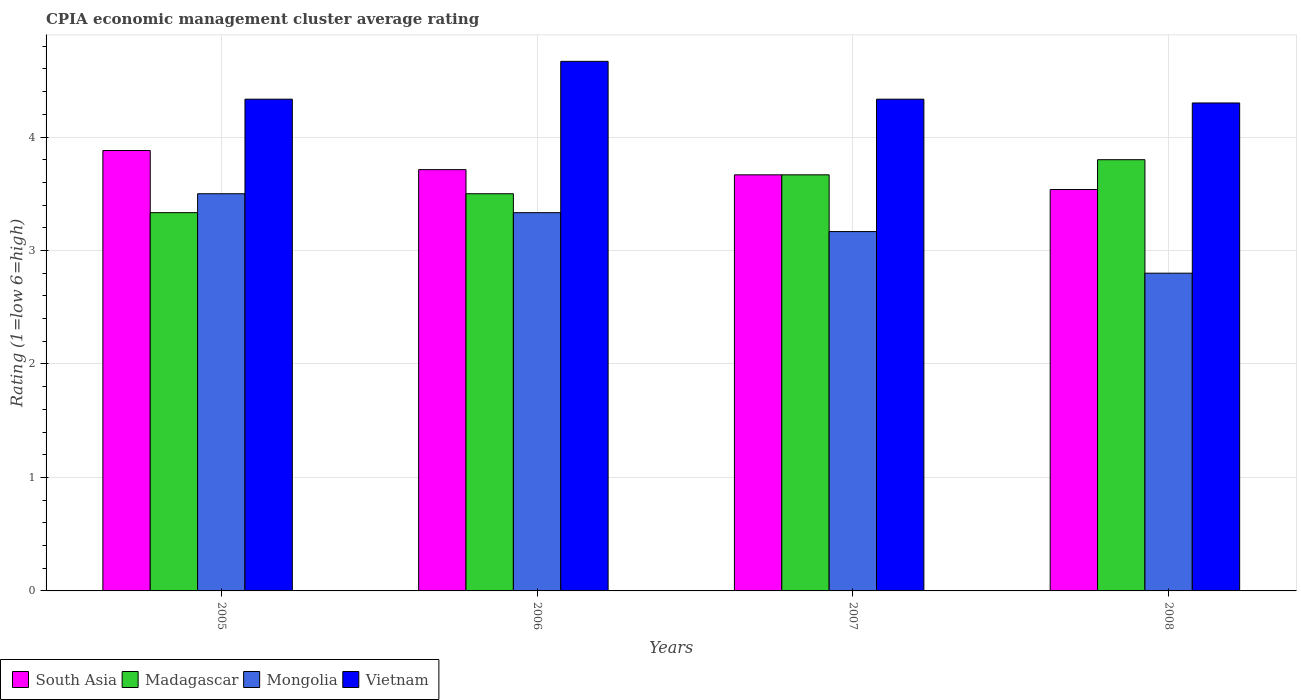Are the number of bars per tick equal to the number of legend labels?
Your response must be concise. Yes. Are the number of bars on each tick of the X-axis equal?
Keep it short and to the point. Yes. How many bars are there on the 2nd tick from the left?
Offer a terse response. 4. How many bars are there on the 1st tick from the right?
Give a very brief answer. 4. What is the label of the 2nd group of bars from the left?
Keep it short and to the point. 2006. In how many cases, is the number of bars for a given year not equal to the number of legend labels?
Offer a terse response. 0. What is the CPIA rating in South Asia in 2006?
Give a very brief answer. 3.71. Across all years, what is the minimum CPIA rating in South Asia?
Provide a succinct answer. 3.54. In which year was the CPIA rating in Mongolia minimum?
Keep it short and to the point. 2008. What is the total CPIA rating in Vietnam in the graph?
Provide a succinct answer. 17.63. What is the difference between the CPIA rating in South Asia in 2007 and that in 2008?
Provide a short and direct response. 0.13. What is the difference between the CPIA rating in Madagascar in 2007 and the CPIA rating in South Asia in 2006?
Provide a succinct answer. -0.05. In the year 2006, what is the difference between the CPIA rating in Madagascar and CPIA rating in Mongolia?
Offer a terse response. 0.17. In how many years, is the CPIA rating in Vietnam greater than 3.8?
Give a very brief answer. 4. What is the ratio of the CPIA rating in Vietnam in 2005 to that in 2007?
Your response must be concise. 1. Is the difference between the CPIA rating in Madagascar in 2005 and 2007 greater than the difference between the CPIA rating in Mongolia in 2005 and 2007?
Your answer should be compact. No. What is the difference between the highest and the second highest CPIA rating in Mongolia?
Provide a short and direct response. 0.17. What is the difference between the highest and the lowest CPIA rating in Mongolia?
Give a very brief answer. 0.7. Is the sum of the CPIA rating in Vietnam in 2005 and 2008 greater than the maximum CPIA rating in Mongolia across all years?
Your response must be concise. Yes. What does the 3rd bar from the left in 2008 represents?
Provide a succinct answer. Mongolia. What does the 1st bar from the right in 2006 represents?
Your answer should be compact. Vietnam. Is it the case that in every year, the sum of the CPIA rating in Madagascar and CPIA rating in Vietnam is greater than the CPIA rating in South Asia?
Give a very brief answer. Yes. How many bars are there?
Offer a terse response. 16. How many years are there in the graph?
Provide a short and direct response. 4. What is the difference between two consecutive major ticks on the Y-axis?
Provide a short and direct response. 1. Does the graph contain any zero values?
Make the answer very short. No. Where does the legend appear in the graph?
Your answer should be very brief. Bottom left. How many legend labels are there?
Ensure brevity in your answer.  4. How are the legend labels stacked?
Offer a terse response. Horizontal. What is the title of the graph?
Your answer should be very brief. CPIA economic management cluster average rating. Does "Brazil" appear as one of the legend labels in the graph?
Make the answer very short. No. What is the Rating (1=low 6=high) in South Asia in 2005?
Provide a short and direct response. 3.88. What is the Rating (1=low 6=high) of Madagascar in 2005?
Ensure brevity in your answer.  3.33. What is the Rating (1=low 6=high) in Mongolia in 2005?
Give a very brief answer. 3.5. What is the Rating (1=low 6=high) of Vietnam in 2005?
Keep it short and to the point. 4.33. What is the Rating (1=low 6=high) in South Asia in 2006?
Give a very brief answer. 3.71. What is the Rating (1=low 6=high) in Mongolia in 2006?
Offer a terse response. 3.33. What is the Rating (1=low 6=high) of Vietnam in 2006?
Keep it short and to the point. 4.67. What is the Rating (1=low 6=high) in South Asia in 2007?
Provide a short and direct response. 3.67. What is the Rating (1=low 6=high) of Madagascar in 2007?
Make the answer very short. 3.67. What is the Rating (1=low 6=high) in Mongolia in 2007?
Your response must be concise. 3.17. What is the Rating (1=low 6=high) in Vietnam in 2007?
Give a very brief answer. 4.33. What is the Rating (1=low 6=high) in South Asia in 2008?
Offer a very short reply. 3.54. Across all years, what is the maximum Rating (1=low 6=high) of South Asia?
Make the answer very short. 3.88. Across all years, what is the maximum Rating (1=low 6=high) of Vietnam?
Offer a very short reply. 4.67. Across all years, what is the minimum Rating (1=low 6=high) in South Asia?
Keep it short and to the point. 3.54. Across all years, what is the minimum Rating (1=low 6=high) of Madagascar?
Your answer should be compact. 3.33. What is the total Rating (1=low 6=high) in South Asia in the graph?
Your answer should be very brief. 14.8. What is the total Rating (1=low 6=high) in Madagascar in the graph?
Keep it short and to the point. 14.3. What is the total Rating (1=low 6=high) in Vietnam in the graph?
Offer a terse response. 17.63. What is the difference between the Rating (1=low 6=high) of South Asia in 2005 and that in 2006?
Your answer should be compact. 0.17. What is the difference between the Rating (1=low 6=high) of Madagascar in 2005 and that in 2006?
Your response must be concise. -0.17. What is the difference between the Rating (1=low 6=high) of Vietnam in 2005 and that in 2006?
Provide a short and direct response. -0.33. What is the difference between the Rating (1=low 6=high) of South Asia in 2005 and that in 2007?
Offer a very short reply. 0.21. What is the difference between the Rating (1=low 6=high) in Madagascar in 2005 and that in 2007?
Provide a short and direct response. -0.33. What is the difference between the Rating (1=low 6=high) in South Asia in 2005 and that in 2008?
Offer a very short reply. 0.34. What is the difference between the Rating (1=low 6=high) in Madagascar in 2005 and that in 2008?
Give a very brief answer. -0.47. What is the difference between the Rating (1=low 6=high) in Mongolia in 2005 and that in 2008?
Your response must be concise. 0.7. What is the difference between the Rating (1=low 6=high) in Vietnam in 2005 and that in 2008?
Keep it short and to the point. 0.03. What is the difference between the Rating (1=low 6=high) of South Asia in 2006 and that in 2007?
Your response must be concise. 0.05. What is the difference between the Rating (1=low 6=high) in Madagascar in 2006 and that in 2007?
Make the answer very short. -0.17. What is the difference between the Rating (1=low 6=high) in Mongolia in 2006 and that in 2007?
Ensure brevity in your answer.  0.17. What is the difference between the Rating (1=low 6=high) in South Asia in 2006 and that in 2008?
Ensure brevity in your answer.  0.17. What is the difference between the Rating (1=low 6=high) of Mongolia in 2006 and that in 2008?
Provide a short and direct response. 0.53. What is the difference between the Rating (1=low 6=high) in Vietnam in 2006 and that in 2008?
Provide a short and direct response. 0.37. What is the difference between the Rating (1=low 6=high) of South Asia in 2007 and that in 2008?
Provide a succinct answer. 0.13. What is the difference between the Rating (1=low 6=high) of Madagascar in 2007 and that in 2008?
Give a very brief answer. -0.13. What is the difference between the Rating (1=low 6=high) of Mongolia in 2007 and that in 2008?
Ensure brevity in your answer.  0.37. What is the difference between the Rating (1=low 6=high) of Vietnam in 2007 and that in 2008?
Make the answer very short. 0.03. What is the difference between the Rating (1=low 6=high) in South Asia in 2005 and the Rating (1=low 6=high) in Madagascar in 2006?
Your response must be concise. 0.38. What is the difference between the Rating (1=low 6=high) in South Asia in 2005 and the Rating (1=low 6=high) in Mongolia in 2006?
Ensure brevity in your answer.  0.55. What is the difference between the Rating (1=low 6=high) of South Asia in 2005 and the Rating (1=low 6=high) of Vietnam in 2006?
Provide a short and direct response. -0.79. What is the difference between the Rating (1=low 6=high) of Madagascar in 2005 and the Rating (1=low 6=high) of Vietnam in 2006?
Ensure brevity in your answer.  -1.33. What is the difference between the Rating (1=low 6=high) in Mongolia in 2005 and the Rating (1=low 6=high) in Vietnam in 2006?
Keep it short and to the point. -1.17. What is the difference between the Rating (1=low 6=high) of South Asia in 2005 and the Rating (1=low 6=high) of Madagascar in 2007?
Provide a short and direct response. 0.21. What is the difference between the Rating (1=low 6=high) of South Asia in 2005 and the Rating (1=low 6=high) of Mongolia in 2007?
Your answer should be very brief. 0.71. What is the difference between the Rating (1=low 6=high) of South Asia in 2005 and the Rating (1=low 6=high) of Vietnam in 2007?
Offer a very short reply. -0.45. What is the difference between the Rating (1=low 6=high) in Madagascar in 2005 and the Rating (1=low 6=high) in Mongolia in 2007?
Provide a succinct answer. 0.17. What is the difference between the Rating (1=low 6=high) of Madagascar in 2005 and the Rating (1=low 6=high) of Vietnam in 2007?
Your answer should be compact. -1. What is the difference between the Rating (1=low 6=high) of Mongolia in 2005 and the Rating (1=low 6=high) of Vietnam in 2007?
Provide a succinct answer. -0.83. What is the difference between the Rating (1=low 6=high) of South Asia in 2005 and the Rating (1=low 6=high) of Madagascar in 2008?
Provide a short and direct response. 0.08. What is the difference between the Rating (1=low 6=high) in South Asia in 2005 and the Rating (1=low 6=high) in Mongolia in 2008?
Provide a succinct answer. 1.08. What is the difference between the Rating (1=low 6=high) of South Asia in 2005 and the Rating (1=low 6=high) of Vietnam in 2008?
Ensure brevity in your answer.  -0.42. What is the difference between the Rating (1=low 6=high) in Madagascar in 2005 and the Rating (1=low 6=high) in Mongolia in 2008?
Ensure brevity in your answer.  0.53. What is the difference between the Rating (1=low 6=high) of Madagascar in 2005 and the Rating (1=low 6=high) of Vietnam in 2008?
Provide a short and direct response. -0.97. What is the difference between the Rating (1=low 6=high) of South Asia in 2006 and the Rating (1=low 6=high) of Madagascar in 2007?
Your response must be concise. 0.05. What is the difference between the Rating (1=low 6=high) of South Asia in 2006 and the Rating (1=low 6=high) of Mongolia in 2007?
Give a very brief answer. 0.55. What is the difference between the Rating (1=low 6=high) in South Asia in 2006 and the Rating (1=low 6=high) in Vietnam in 2007?
Your response must be concise. -0.62. What is the difference between the Rating (1=low 6=high) of Madagascar in 2006 and the Rating (1=low 6=high) of Mongolia in 2007?
Make the answer very short. 0.33. What is the difference between the Rating (1=low 6=high) in South Asia in 2006 and the Rating (1=low 6=high) in Madagascar in 2008?
Provide a short and direct response. -0.09. What is the difference between the Rating (1=low 6=high) in South Asia in 2006 and the Rating (1=low 6=high) in Mongolia in 2008?
Offer a terse response. 0.91. What is the difference between the Rating (1=low 6=high) of South Asia in 2006 and the Rating (1=low 6=high) of Vietnam in 2008?
Your answer should be very brief. -0.59. What is the difference between the Rating (1=low 6=high) in Madagascar in 2006 and the Rating (1=low 6=high) in Mongolia in 2008?
Your answer should be very brief. 0.7. What is the difference between the Rating (1=low 6=high) in Madagascar in 2006 and the Rating (1=low 6=high) in Vietnam in 2008?
Your answer should be very brief. -0.8. What is the difference between the Rating (1=low 6=high) of Mongolia in 2006 and the Rating (1=low 6=high) of Vietnam in 2008?
Provide a short and direct response. -0.97. What is the difference between the Rating (1=low 6=high) in South Asia in 2007 and the Rating (1=low 6=high) in Madagascar in 2008?
Provide a succinct answer. -0.13. What is the difference between the Rating (1=low 6=high) in South Asia in 2007 and the Rating (1=low 6=high) in Mongolia in 2008?
Ensure brevity in your answer.  0.87. What is the difference between the Rating (1=low 6=high) of South Asia in 2007 and the Rating (1=low 6=high) of Vietnam in 2008?
Provide a succinct answer. -0.63. What is the difference between the Rating (1=low 6=high) in Madagascar in 2007 and the Rating (1=low 6=high) in Mongolia in 2008?
Your answer should be compact. 0.87. What is the difference between the Rating (1=low 6=high) of Madagascar in 2007 and the Rating (1=low 6=high) of Vietnam in 2008?
Provide a short and direct response. -0.63. What is the difference between the Rating (1=low 6=high) of Mongolia in 2007 and the Rating (1=low 6=high) of Vietnam in 2008?
Make the answer very short. -1.13. What is the average Rating (1=low 6=high) of South Asia per year?
Offer a terse response. 3.7. What is the average Rating (1=low 6=high) in Madagascar per year?
Your answer should be very brief. 3.58. What is the average Rating (1=low 6=high) in Vietnam per year?
Make the answer very short. 4.41. In the year 2005, what is the difference between the Rating (1=low 6=high) in South Asia and Rating (1=low 6=high) in Madagascar?
Offer a very short reply. 0.55. In the year 2005, what is the difference between the Rating (1=low 6=high) in South Asia and Rating (1=low 6=high) in Mongolia?
Your answer should be very brief. 0.38. In the year 2005, what is the difference between the Rating (1=low 6=high) of South Asia and Rating (1=low 6=high) of Vietnam?
Provide a short and direct response. -0.45. In the year 2005, what is the difference between the Rating (1=low 6=high) in Madagascar and Rating (1=low 6=high) in Mongolia?
Your response must be concise. -0.17. In the year 2006, what is the difference between the Rating (1=low 6=high) in South Asia and Rating (1=low 6=high) in Madagascar?
Ensure brevity in your answer.  0.21. In the year 2006, what is the difference between the Rating (1=low 6=high) of South Asia and Rating (1=low 6=high) of Mongolia?
Your response must be concise. 0.38. In the year 2006, what is the difference between the Rating (1=low 6=high) of South Asia and Rating (1=low 6=high) of Vietnam?
Provide a short and direct response. -0.95. In the year 2006, what is the difference between the Rating (1=low 6=high) in Madagascar and Rating (1=low 6=high) in Vietnam?
Ensure brevity in your answer.  -1.17. In the year 2006, what is the difference between the Rating (1=low 6=high) of Mongolia and Rating (1=low 6=high) of Vietnam?
Keep it short and to the point. -1.33. In the year 2007, what is the difference between the Rating (1=low 6=high) in South Asia and Rating (1=low 6=high) in Madagascar?
Offer a very short reply. 0. In the year 2007, what is the difference between the Rating (1=low 6=high) in South Asia and Rating (1=low 6=high) in Mongolia?
Offer a terse response. 0.5. In the year 2007, what is the difference between the Rating (1=low 6=high) in Madagascar and Rating (1=low 6=high) in Vietnam?
Keep it short and to the point. -0.67. In the year 2007, what is the difference between the Rating (1=low 6=high) of Mongolia and Rating (1=low 6=high) of Vietnam?
Your answer should be compact. -1.17. In the year 2008, what is the difference between the Rating (1=low 6=high) in South Asia and Rating (1=low 6=high) in Madagascar?
Provide a short and direct response. -0.26. In the year 2008, what is the difference between the Rating (1=low 6=high) in South Asia and Rating (1=low 6=high) in Mongolia?
Give a very brief answer. 0.74. In the year 2008, what is the difference between the Rating (1=low 6=high) in South Asia and Rating (1=low 6=high) in Vietnam?
Ensure brevity in your answer.  -0.76. What is the ratio of the Rating (1=low 6=high) in South Asia in 2005 to that in 2006?
Ensure brevity in your answer.  1.05. What is the ratio of the Rating (1=low 6=high) of South Asia in 2005 to that in 2007?
Your answer should be very brief. 1.06. What is the ratio of the Rating (1=low 6=high) in Mongolia in 2005 to that in 2007?
Give a very brief answer. 1.11. What is the ratio of the Rating (1=low 6=high) in South Asia in 2005 to that in 2008?
Provide a succinct answer. 1.1. What is the ratio of the Rating (1=low 6=high) of Madagascar in 2005 to that in 2008?
Your response must be concise. 0.88. What is the ratio of the Rating (1=low 6=high) in Mongolia in 2005 to that in 2008?
Give a very brief answer. 1.25. What is the ratio of the Rating (1=low 6=high) of South Asia in 2006 to that in 2007?
Provide a succinct answer. 1.01. What is the ratio of the Rating (1=low 6=high) of Madagascar in 2006 to that in 2007?
Make the answer very short. 0.95. What is the ratio of the Rating (1=low 6=high) of Mongolia in 2006 to that in 2007?
Give a very brief answer. 1.05. What is the ratio of the Rating (1=low 6=high) of Vietnam in 2006 to that in 2007?
Your answer should be very brief. 1.08. What is the ratio of the Rating (1=low 6=high) in South Asia in 2006 to that in 2008?
Offer a very short reply. 1.05. What is the ratio of the Rating (1=low 6=high) in Madagascar in 2006 to that in 2008?
Give a very brief answer. 0.92. What is the ratio of the Rating (1=low 6=high) of Mongolia in 2006 to that in 2008?
Provide a succinct answer. 1.19. What is the ratio of the Rating (1=low 6=high) in Vietnam in 2006 to that in 2008?
Your response must be concise. 1.09. What is the ratio of the Rating (1=low 6=high) in South Asia in 2007 to that in 2008?
Give a very brief answer. 1.04. What is the ratio of the Rating (1=low 6=high) of Madagascar in 2007 to that in 2008?
Offer a terse response. 0.96. What is the ratio of the Rating (1=low 6=high) in Mongolia in 2007 to that in 2008?
Keep it short and to the point. 1.13. What is the ratio of the Rating (1=low 6=high) in Vietnam in 2007 to that in 2008?
Provide a short and direct response. 1.01. What is the difference between the highest and the second highest Rating (1=low 6=high) in South Asia?
Keep it short and to the point. 0.17. What is the difference between the highest and the second highest Rating (1=low 6=high) of Madagascar?
Provide a short and direct response. 0.13. What is the difference between the highest and the second highest Rating (1=low 6=high) of Mongolia?
Provide a short and direct response. 0.17. What is the difference between the highest and the lowest Rating (1=low 6=high) of South Asia?
Offer a terse response. 0.34. What is the difference between the highest and the lowest Rating (1=low 6=high) in Madagascar?
Keep it short and to the point. 0.47. What is the difference between the highest and the lowest Rating (1=low 6=high) in Mongolia?
Provide a short and direct response. 0.7. What is the difference between the highest and the lowest Rating (1=low 6=high) in Vietnam?
Provide a succinct answer. 0.37. 